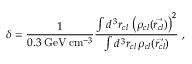<formula> <loc_0><loc_0><loc_500><loc_500>\delta = \frac { 1 } { 0 . 3 \, G e V \, c m ^ { - 3 } } \frac { \int d ^ { \, 3 } r _ { c l } \, \left ( \rho _ { c l } ( \vec { r _ { c l } } ) \right ) ^ { 2 } } { \int d ^ { \, 3 } r _ { c l } \, \rho _ { c l } ( \vec { r _ { c l } } ) } \, ,</formula> 